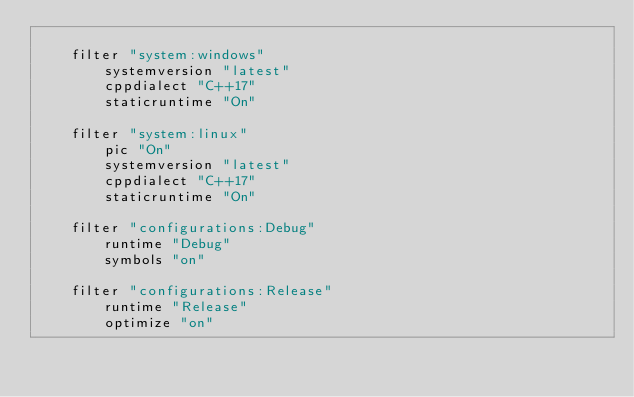Convert code to text. <code><loc_0><loc_0><loc_500><loc_500><_Lua_>
	filter "system:windows"
		systemversion "latest"
		cppdialect "C++17"
		staticruntime "On"

	filter "system:linux"
		pic "On"
		systemversion "latest"
		cppdialect "C++17"
		staticruntime "On"

	filter "configurations:Debug"
		runtime "Debug"
		symbols "on"

	filter "configurations:Release"
		runtime "Release"
		optimize "on"
</code> 